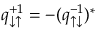Convert formula to latex. <formula><loc_0><loc_0><loc_500><loc_500>q _ { \downarrow \uparrow } ^ { + 1 } = - ( q _ { \uparrow \downarrow } ^ { - 1 } ) ^ { * }</formula> 